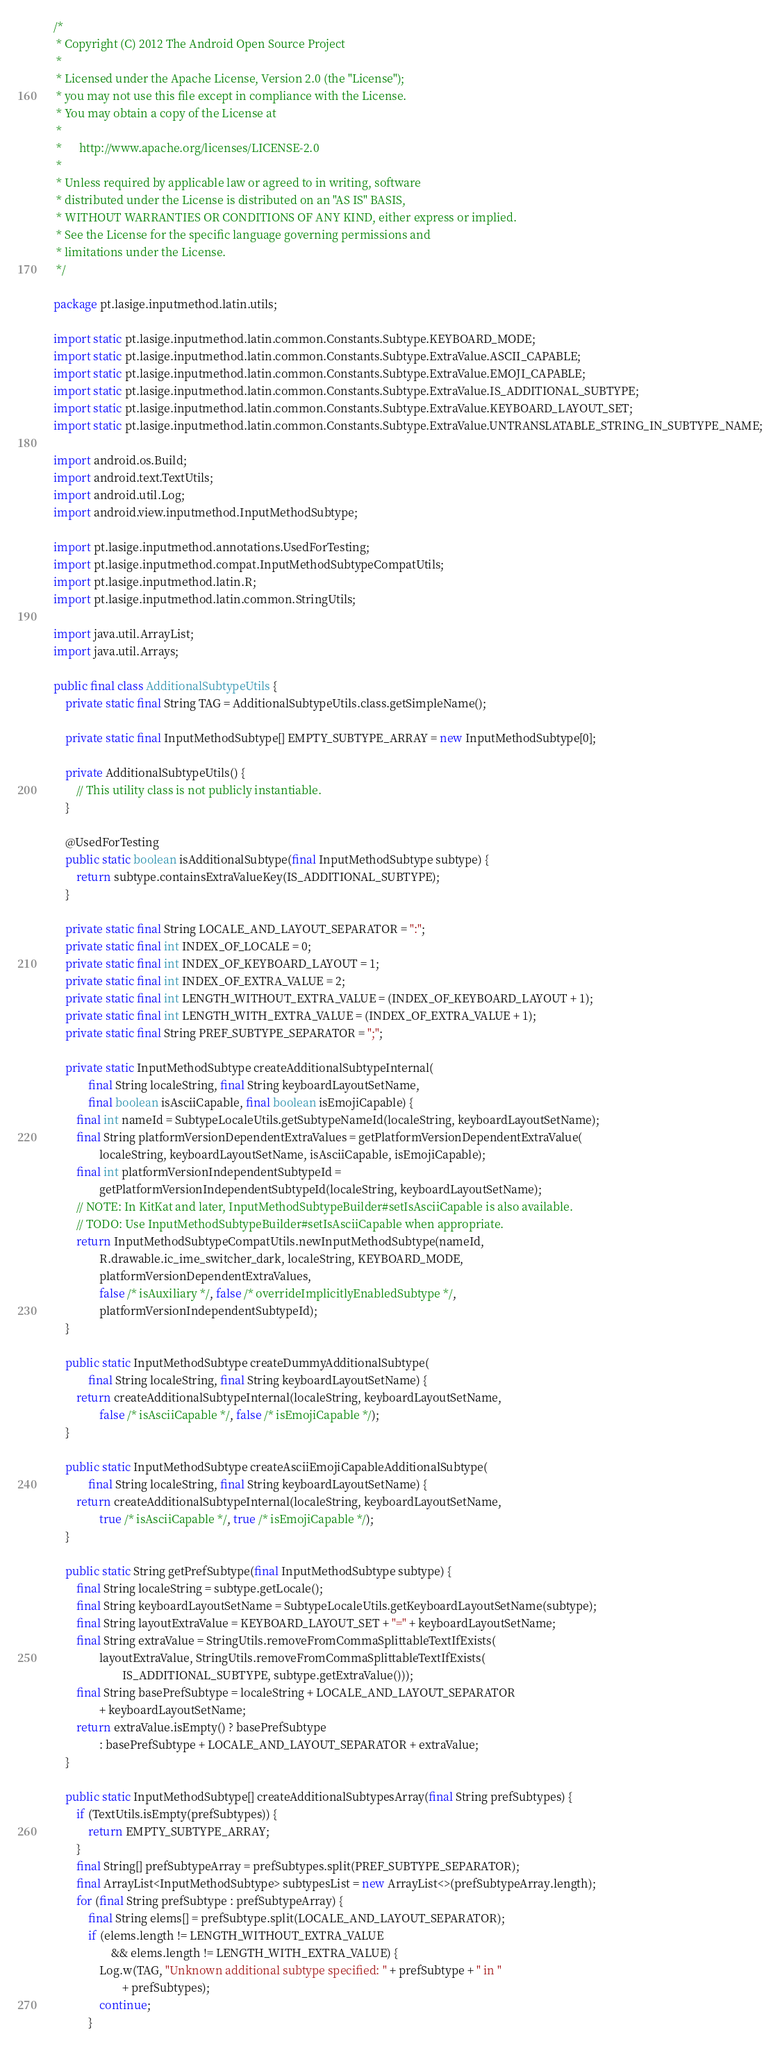Convert code to text. <code><loc_0><loc_0><loc_500><loc_500><_Java_>/*
 * Copyright (C) 2012 The Android Open Source Project
 *
 * Licensed under the Apache License, Version 2.0 (the "License");
 * you may not use this file except in compliance with the License.
 * You may obtain a copy of the License at
 *
 *      http://www.apache.org/licenses/LICENSE-2.0
 *
 * Unless required by applicable law or agreed to in writing, software
 * distributed under the License is distributed on an "AS IS" BASIS,
 * WITHOUT WARRANTIES OR CONDITIONS OF ANY KIND, either express or implied.
 * See the License for the specific language governing permissions and
 * limitations under the License.
 */

package pt.lasige.inputmethod.latin.utils;

import static pt.lasige.inputmethod.latin.common.Constants.Subtype.KEYBOARD_MODE;
import static pt.lasige.inputmethod.latin.common.Constants.Subtype.ExtraValue.ASCII_CAPABLE;
import static pt.lasige.inputmethod.latin.common.Constants.Subtype.ExtraValue.EMOJI_CAPABLE;
import static pt.lasige.inputmethod.latin.common.Constants.Subtype.ExtraValue.IS_ADDITIONAL_SUBTYPE;
import static pt.lasige.inputmethod.latin.common.Constants.Subtype.ExtraValue.KEYBOARD_LAYOUT_SET;
import static pt.lasige.inputmethod.latin.common.Constants.Subtype.ExtraValue.UNTRANSLATABLE_STRING_IN_SUBTYPE_NAME;

import android.os.Build;
import android.text.TextUtils;
import android.util.Log;
import android.view.inputmethod.InputMethodSubtype;

import pt.lasige.inputmethod.annotations.UsedForTesting;
import pt.lasige.inputmethod.compat.InputMethodSubtypeCompatUtils;
import pt.lasige.inputmethod.latin.R;
import pt.lasige.inputmethod.latin.common.StringUtils;

import java.util.ArrayList;
import java.util.Arrays;

public final class AdditionalSubtypeUtils {
    private static final String TAG = AdditionalSubtypeUtils.class.getSimpleName();

    private static final InputMethodSubtype[] EMPTY_SUBTYPE_ARRAY = new InputMethodSubtype[0];

    private AdditionalSubtypeUtils() {
        // This utility class is not publicly instantiable.
    }

    @UsedForTesting
    public static boolean isAdditionalSubtype(final InputMethodSubtype subtype) {
        return subtype.containsExtraValueKey(IS_ADDITIONAL_SUBTYPE);
    }

    private static final String LOCALE_AND_LAYOUT_SEPARATOR = ":";
    private static final int INDEX_OF_LOCALE = 0;
    private static final int INDEX_OF_KEYBOARD_LAYOUT = 1;
    private static final int INDEX_OF_EXTRA_VALUE = 2;
    private static final int LENGTH_WITHOUT_EXTRA_VALUE = (INDEX_OF_KEYBOARD_LAYOUT + 1);
    private static final int LENGTH_WITH_EXTRA_VALUE = (INDEX_OF_EXTRA_VALUE + 1);
    private static final String PREF_SUBTYPE_SEPARATOR = ";";

    private static InputMethodSubtype createAdditionalSubtypeInternal(
            final String localeString, final String keyboardLayoutSetName,
            final boolean isAsciiCapable, final boolean isEmojiCapable) {
        final int nameId = SubtypeLocaleUtils.getSubtypeNameId(localeString, keyboardLayoutSetName);
        final String platformVersionDependentExtraValues = getPlatformVersionDependentExtraValue(
                localeString, keyboardLayoutSetName, isAsciiCapable, isEmojiCapable);
        final int platformVersionIndependentSubtypeId =
                getPlatformVersionIndependentSubtypeId(localeString, keyboardLayoutSetName);
        // NOTE: In KitKat and later, InputMethodSubtypeBuilder#setIsAsciiCapable is also available.
        // TODO: Use InputMethodSubtypeBuilder#setIsAsciiCapable when appropriate.
        return InputMethodSubtypeCompatUtils.newInputMethodSubtype(nameId,
                R.drawable.ic_ime_switcher_dark, localeString, KEYBOARD_MODE,
                platformVersionDependentExtraValues,
                false /* isAuxiliary */, false /* overrideImplicitlyEnabledSubtype */,
                platformVersionIndependentSubtypeId);
    }

    public static InputMethodSubtype createDummyAdditionalSubtype(
            final String localeString, final String keyboardLayoutSetName) {
        return createAdditionalSubtypeInternal(localeString, keyboardLayoutSetName,
                false /* isAsciiCapable */, false /* isEmojiCapable */);
    }

    public static InputMethodSubtype createAsciiEmojiCapableAdditionalSubtype(
            final String localeString, final String keyboardLayoutSetName) {
        return createAdditionalSubtypeInternal(localeString, keyboardLayoutSetName,
                true /* isAsciiCapable */, true /* isEmojiCapable */);
    }

    public static String getPrefSubtype(final InputMethodSubtype subtype) {
        final String localeString = subtype.getLocale();
        final String keyboardLayoutSetName = SubtypeLocaleUtils.getKeyboardLayoutSetName(subtype);
        final String layoutExtraValue = KEYBOARD_LAYOUT_SET + "=" + keyboardLayoutSetName;
        final String extraValue = StringUtils.removeFromCommaSplittableTextIfExists(
                layoutExtraValue, StringUtils.removeFromCommaSplittableTextIfExists(
                        IS_ADDITIONAL_SUBTYPE, subtype.getExtraValue()));
        final String basePrefSubtype = localeString + LOCALE_AND_LAYOUT_SEPARATOR
                + keyboardLayoutSetName;
        return extraValue.isEmpty() ? basePrefSubtype
                : basePrefSubtype + LOCALE_AND_LAYOUT_SEPARATOR + extraValue;
    }

    public static InputMethodSubtype[] createAdditionalSubtypesArray(final String prefSubtypes) {
        if (TextUtils.isEmpty(prefSubtypes)) {
            return EMPTY_SUBTYPE_ARRAY;
        }
        final String[] prefSubtypeArray = prefSubtypes.split(PREF_SUBTYPE_SEPARATOR);
        final ArrayList<InputMethodSubtype> subtypesList = new ArrayList<>(prefSubtypeArray.length);
        for (final String prefSubtype : prefSubtypeArray) {
            final String elems[] = prefSubtype.split(LOCALE_AND_LAYOUT_SEPARATOR);
            if (elems.length != LENGTH_WITHOUT_EXTRA_VALUE
                    && elems.length != LENGTH_WITH_EXTRA_VALUE) {
                Log.w(TAG, "Unknown additional subtype specified: " + prefSubtype + " in "
                        + prefSubtypes);
                continue;
            }</code> 